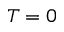<formula> <loc_0><loc_0><loc_500><loc_500>T = 0</formula> 